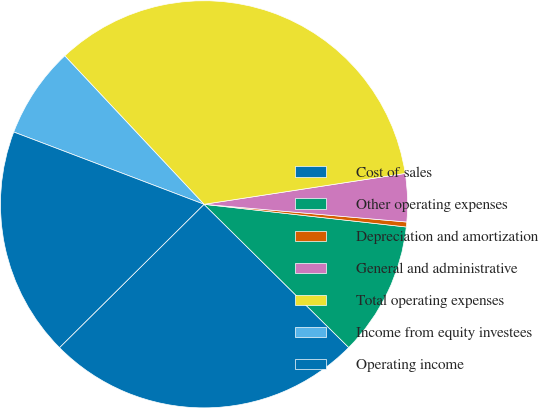Convert chart to OTSL. <chart><loc_0><loc_0><loc_500><loc_500><pie_chart><fcel>Cost of sales<fcel>Other operating expenses<fcel>Depreciation and amortization<fcel>General and administrative<fcel>Total operating expenses<fcel>Income from equity investees<fcel>Operating income<nl><fcel>25.15%<fcel>10.64%<fcel>0.39%<fcel>3.81%<fcel>34.57%<fcel>7.23%<fcel>18.21%<nl></chart> 